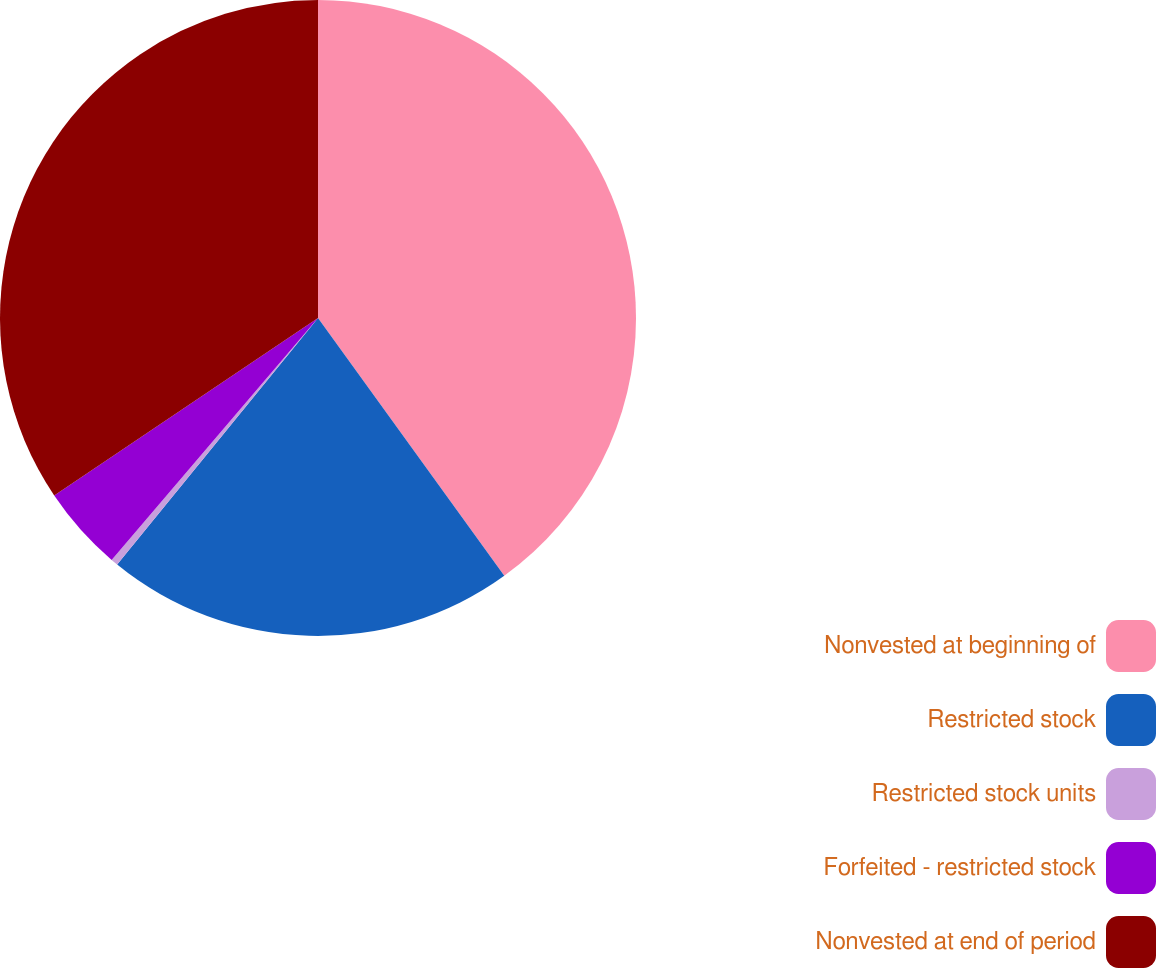<chart> <loc_0><loc_0><loc_500><loc_500><pie_chart><fcel>Nonvested at beginning of<fcel>Restricted stock<fcel>Restricted stock units<fcel>Forfeited - restricted stock<fcel>Nonvested at end of period<nl><fcel>40.04%<fcel>20.84%<fcel>0.36%<fcel>4.33%<fcel>34.43%<nl></chart> 